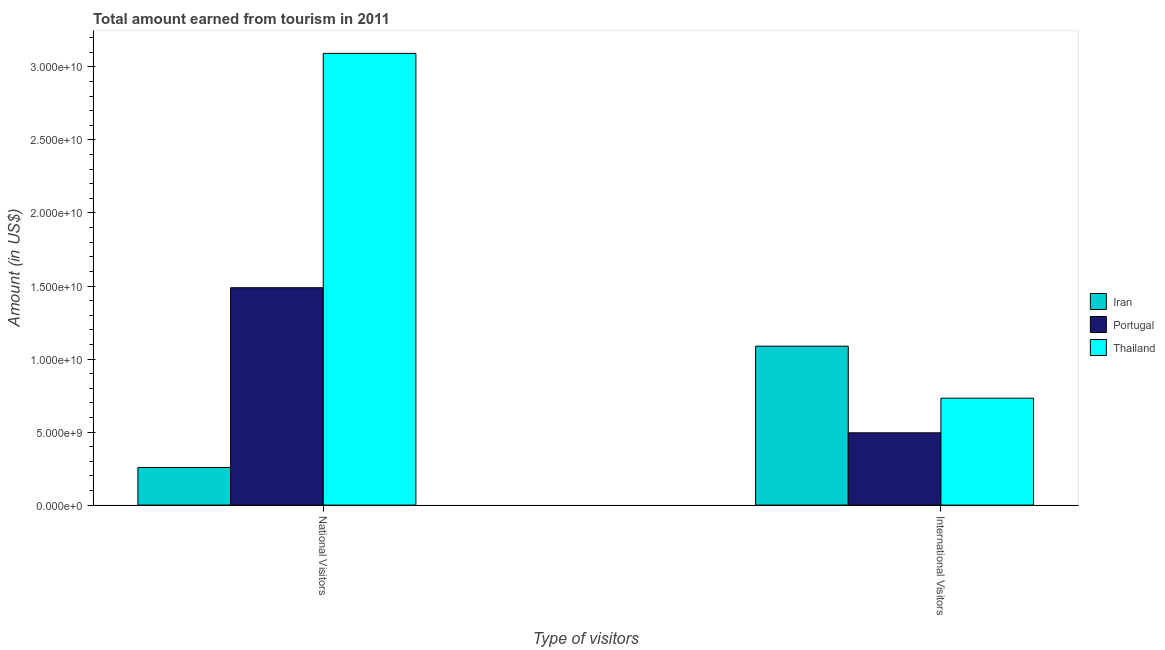How many groups of bars are there?
Your response must be concise. 2. Are the number of bars on each tick of the X-axis equal?
Make the answer very short. Yes. How many bars are there on the 2nd tick from the left?
Give a very brief answer. 3. What is the label of the 2nd group of bars from the left?
Your response must be concise. International Visitors. What is the amount earned from national visitors in Iran?
Your answer should be compact. 2.57e+09. Across all countries, what is the maximum amount earned from national visitors?
Provide a short and direct response. 3.09e+1. Across all countries, what is the minimum amount earned from international visitors?
Offer a very short reply. 4.95e+09. In which country was the amount earned from national visitors maximum?
Your answer should be compact. Thailand. In which country was the amount earned from international visitors minimum?
Provide a short and direct response. Portugal. What is the total amount earned from international visitors in the graph?
Your answer should be very brief. 2.31e+1. What is the difference between the amount earned from international visitors in Iran and that in Portugal?
Provide a short and direct response. 5.93e+09. What is the difference between the amount earned from international visitors in Iran and the amount earned from national visitors in Thailand?
Offer a terse response. -2.00e+1. What is the average amount earned from national visitors per country?
Provide a short and direct response. 1.61e+1. What is the difference between the amount earned from international visitors and amount earned from national visitors in Portugal?
Give a very brief answer. -9.93e+09. In how many countries, is the amount earned from international visitors greater than 11000000000 US$?
Keep it short and to the point. 0. What is the ratio of the amount earned from national visitors in Iran to that in Portugal?
Your response must be concise. 0.17. Is the amount earned from international visitors in Iran less than that in Portugal?
Ensure brevity in your answer.  No. What does the 2nd bar from the left in National Visitors represents?
Your answer should be compact. Portugal. What does the 1st bar from the right in International Visitors represents?
Make the answer very short. Thailand. Are all the bars in the graph horizontal?
Provide a short and direct response. No. How many countries are there in the graph?
Give a very brief answer. 3. What is the difference between two consecutive major ticks on the Y-axis?
Provide a short and direct response. 5.00e+09. Are the values on the major ticks of Y-axis written in scientific E-notation?
Your response must be concise. Yes. Where does the legend appear in the graph?
Offer a terse response. Center right. How many legend labels are there?
Provide a succinct answer. 3. What is the title of the graph?
Make the answer very short. Total amount earned from tourism in 2011. What is the label or title of the X-axis?
Offer a terse response. Type of visitors. What is the Amount (in US$) in Iran in National Visitors?
Make the answer very short. 2.57e+09. What is the Amount (in US$) in Portugal in National Visitors?
Ensure brevity in your answer.  1.49e+1. What is the Amount (in US$) of Thailand in National Visitors?
Your answer should be very brief. 3.09e+1. What is the Amount (in US$) of Iran in International Visitors?
Make the answer very short. 1.09e+1. What is the Amount (in US$) in Portugal in International Visitors?
Give a very brief answer. 4.95e+09. What is the Amount (in US$) in Thailand in International Visitors?
Offer a terse response. 7.32e+09. Across all Type of visitors, what is the maximum Amount (in US$) of Iran?
Your response must be concise. 1.09e+1. Across all Type of visitors, what is the maximum Amount (in US$) of Portugal?
Ensure brevity in your answer.  1.49e+1. Across all Type of visitors, what is the maximum Amount (in US$) of Thailand?
Provide a short and direct response. 3.09e+1. Across all Type of visitors, what is the minimum Amount (in US$) of Iran?
Ensure brevity in your answer.  2.57e+09. Across all Type of visitors, what is the minimum Amount (in US$) in Portugal?
Offer a very short reply. 4.95e+09. Across all Type of visitors, what is the minimum Amount (in US$) in Thailand?
Your answer should be very brief. 7.32e+09. What is the total Amount (in US$) of Iran in the graph?
Ensure brevity in your answer.  1.35e+1. What is the total Amount (in US$) in Portugal in the graph?
Make the answer very short. 1.98e+1. What is the total Amount (in US$) of Thailand in the graph?
Offer a terse response. 3.82e+1. What is the difference between the Amount (in US$) of Iran in National Visitors and that in International Visitors?
Offer a terse response. -8.31e+09. What is the difference between the Amount (in US$) in Portugal in National Visitors and that in International Visitors?
Offer a very short reply. 9.93e+09. What is the difference between the Amount (in US$) in Thailand in National Visitors and that in International Visitors?
Keep it short and to the point. 2.36e+1. What is the difference between the Amount (in US$) in Iran in National Visitors and the Amount (in US$) in Portugal in International Visitors?
Offer a very short reply. -2.37e+09. What is the difference between the Amount (in US$) in Iran in National Visitors and the Amount (in US$) in Thailand in International Visitors?
Offer a very short reply. -4.75e+09. What is the difference between the Amount (in US$) in Portugal in National Visitors and the Amount (in US$) in Thailand in International Visitors?
Make the answer very short. 7.56e+09. What is the average Amount (in US$) of Iran per Type of visitors?
Your answer should be very brief. 6.73e+09. What is the average Amount (in US$) in Portugal per Type of visitors?
Offer a very short reply. 9.92e+09. What is the average Amount (in US$) of Thailand per Type of visitors?
Your answer should be very brief. 1.91e+1. What is the difference between the Amount (in US$) in Iran and Amount (in US$) in Portugal in National Visitors?
Provide a short and direct response. -1.23e+1. What is the difference between the Amount (in US$) in Iran and Amount (in US$) in Thailand in National Visitors?
Ensure brevity in your answer.  -2.84e+1. What is the difference between the Amount (in US$) of Portugal and Amount (in US$) of Thailand in National Visitors?
Offer a very short reply. -1.60e+1. What is the difference between the Amount (in US$) of Iran and Amount (in US$) of Portugal in International Visitors?
Keep it short and to the point. 5.93e+09. What is the difference between the Amount (in US$) of Iran and Amount (in US$) of Thailand in International Visitors?
Your answer should be compact. 3.56e+09. What is the difference between the Amount (in US$) of Portugal and Amount (in US$) of Thailand in International Visitors?
Your response must be concise. -2.37e+09. What is the ratio of the Amount (in US$) in Iran in National Visitors to that in International Visitors?
Your answer should be very brief. 0.24. What is the ratio of the Amount (in US$) in Portugal in National Visitors to that in International Visitors?
Provide a short and direct response. 3.01. What is the ratio of the Amount (in US$) in Thailand in National Visitors to that in International Visitors?
Offer a terse response. 4.22. What is the difference between the highest and the second highest Amount (in US$) of Iran?
Provide a short and direct response. 8.31e+09. What is the difference between the highest and the second highest Amount (in US$) of Portugal?
Your answer should be very brief. 9.93e+09. What is the difference between the highest and the second highest Amount (in US$) in Thailand?
Offer a terse response. 2.36e+1. What is the difference between the highest and the lowest Amount (in US$) of Iran?
Your response must be concise. 8.31e+09. What is the difference between the highest and the lowest Amount (in US$) in Portugal?
Your answer should be very brief. 9.93e+09. What is the difference between the highest and the lowest Amount (in US$) of Thailand?
Make the answer very short. 2.36e+1. 